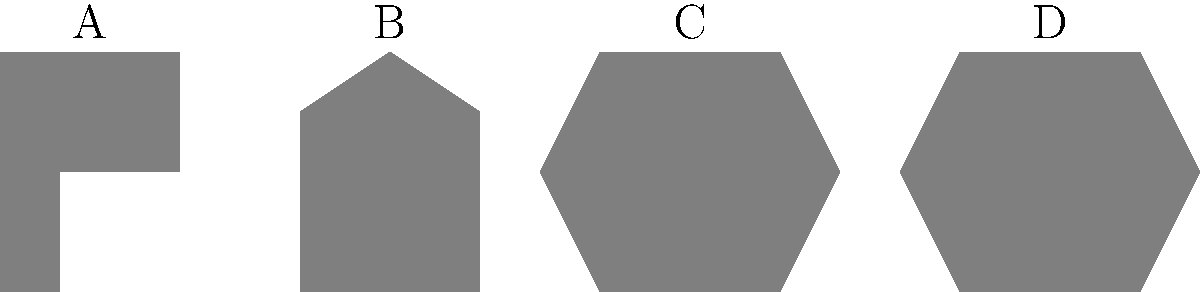Identify the iconic sci-fi spaceship represented by silhouette B in the image above. Which famous franchise does it belong to? Let's analyze each silhouette to determine which iconic sci-fi spaceship is represented by B:

1. Silhouette A: This shape resembles the USS Enterprise from Star Trek, with its saucer section and elongated body.

2. Silhouette B: This triangular shape is distinctive of the Star Destroyers from the Star Wars franchise. The pointed front and wider rear are characteristic of Imperial Star Destroyers.

3. Silhouette C: This silhouette appears to be the Millennium Falcon from Star Wars, with its circular body and offset cockpit.

4. Silhouette D: This shape is reminiscent of a Cylon Basestar from Battlestar Galactica, with its Y-shaped design.

Given the question asks specifically about silhouette B, we can conclude that it represents a Star Destroyer from the Star Wars franchise. Star Destroyers are iconic vessels of the Galactic Empire, first appearing in the original Star Wars film (Episode IV: A New Hope) in 1977 and featuring prominently throughout the series.
Answer: Star Wars 